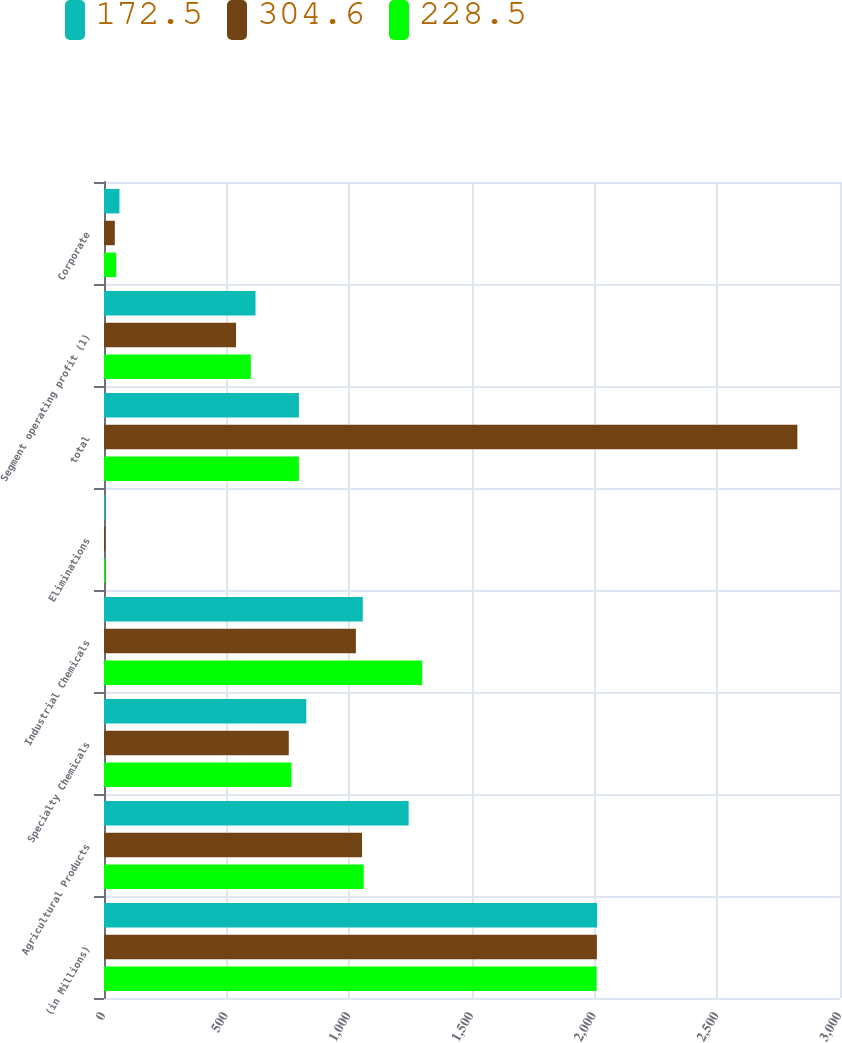<chart> <loc_0><loc_0><loc_500><loc_500><stacked_bar_chart><ecel><fcel>(in Millions)<fcel>Agricultural Products<fcel>Specialty Chemicals<fcel>Industrial Chemicals<fcel>Eliminations<fcel>total<fcel>Segment operating profit (1)<fcel>Corporate<nl><fcel>172.5<fcel>2010<fcel>1241.8<fcel>824.5<fcel>1054.8<fcel>4.8<fcel>794.5<fcel>617.6<fcel>63<nl><fcel>304.6<fcel>2009<fcel>1051.6<fcel>753.1<fcel>1026.7<fcel>5.2<fcel>2826.2<fcel>538.2<fcel>44.1<nl><fcel>228.5<fcel>2008<fcel>1058.7<fcel>764.5<fcel>1296.9<fcel>4.8<fcel>794.5<fcel>598.5<fcel>49.8<nl></chart> 